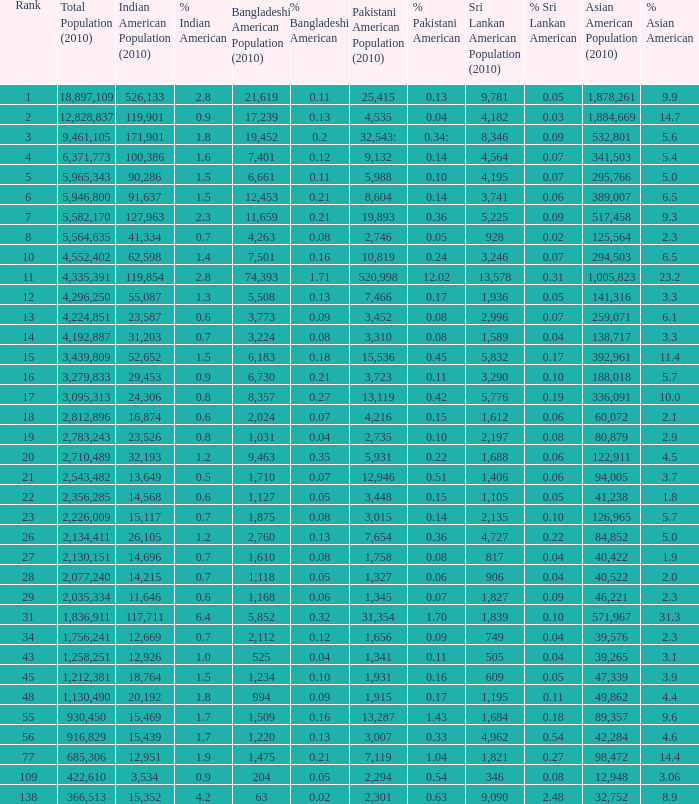What's the total population when there are 5.7% Asian American and fewer than 126,965 Asian American Population? None. 